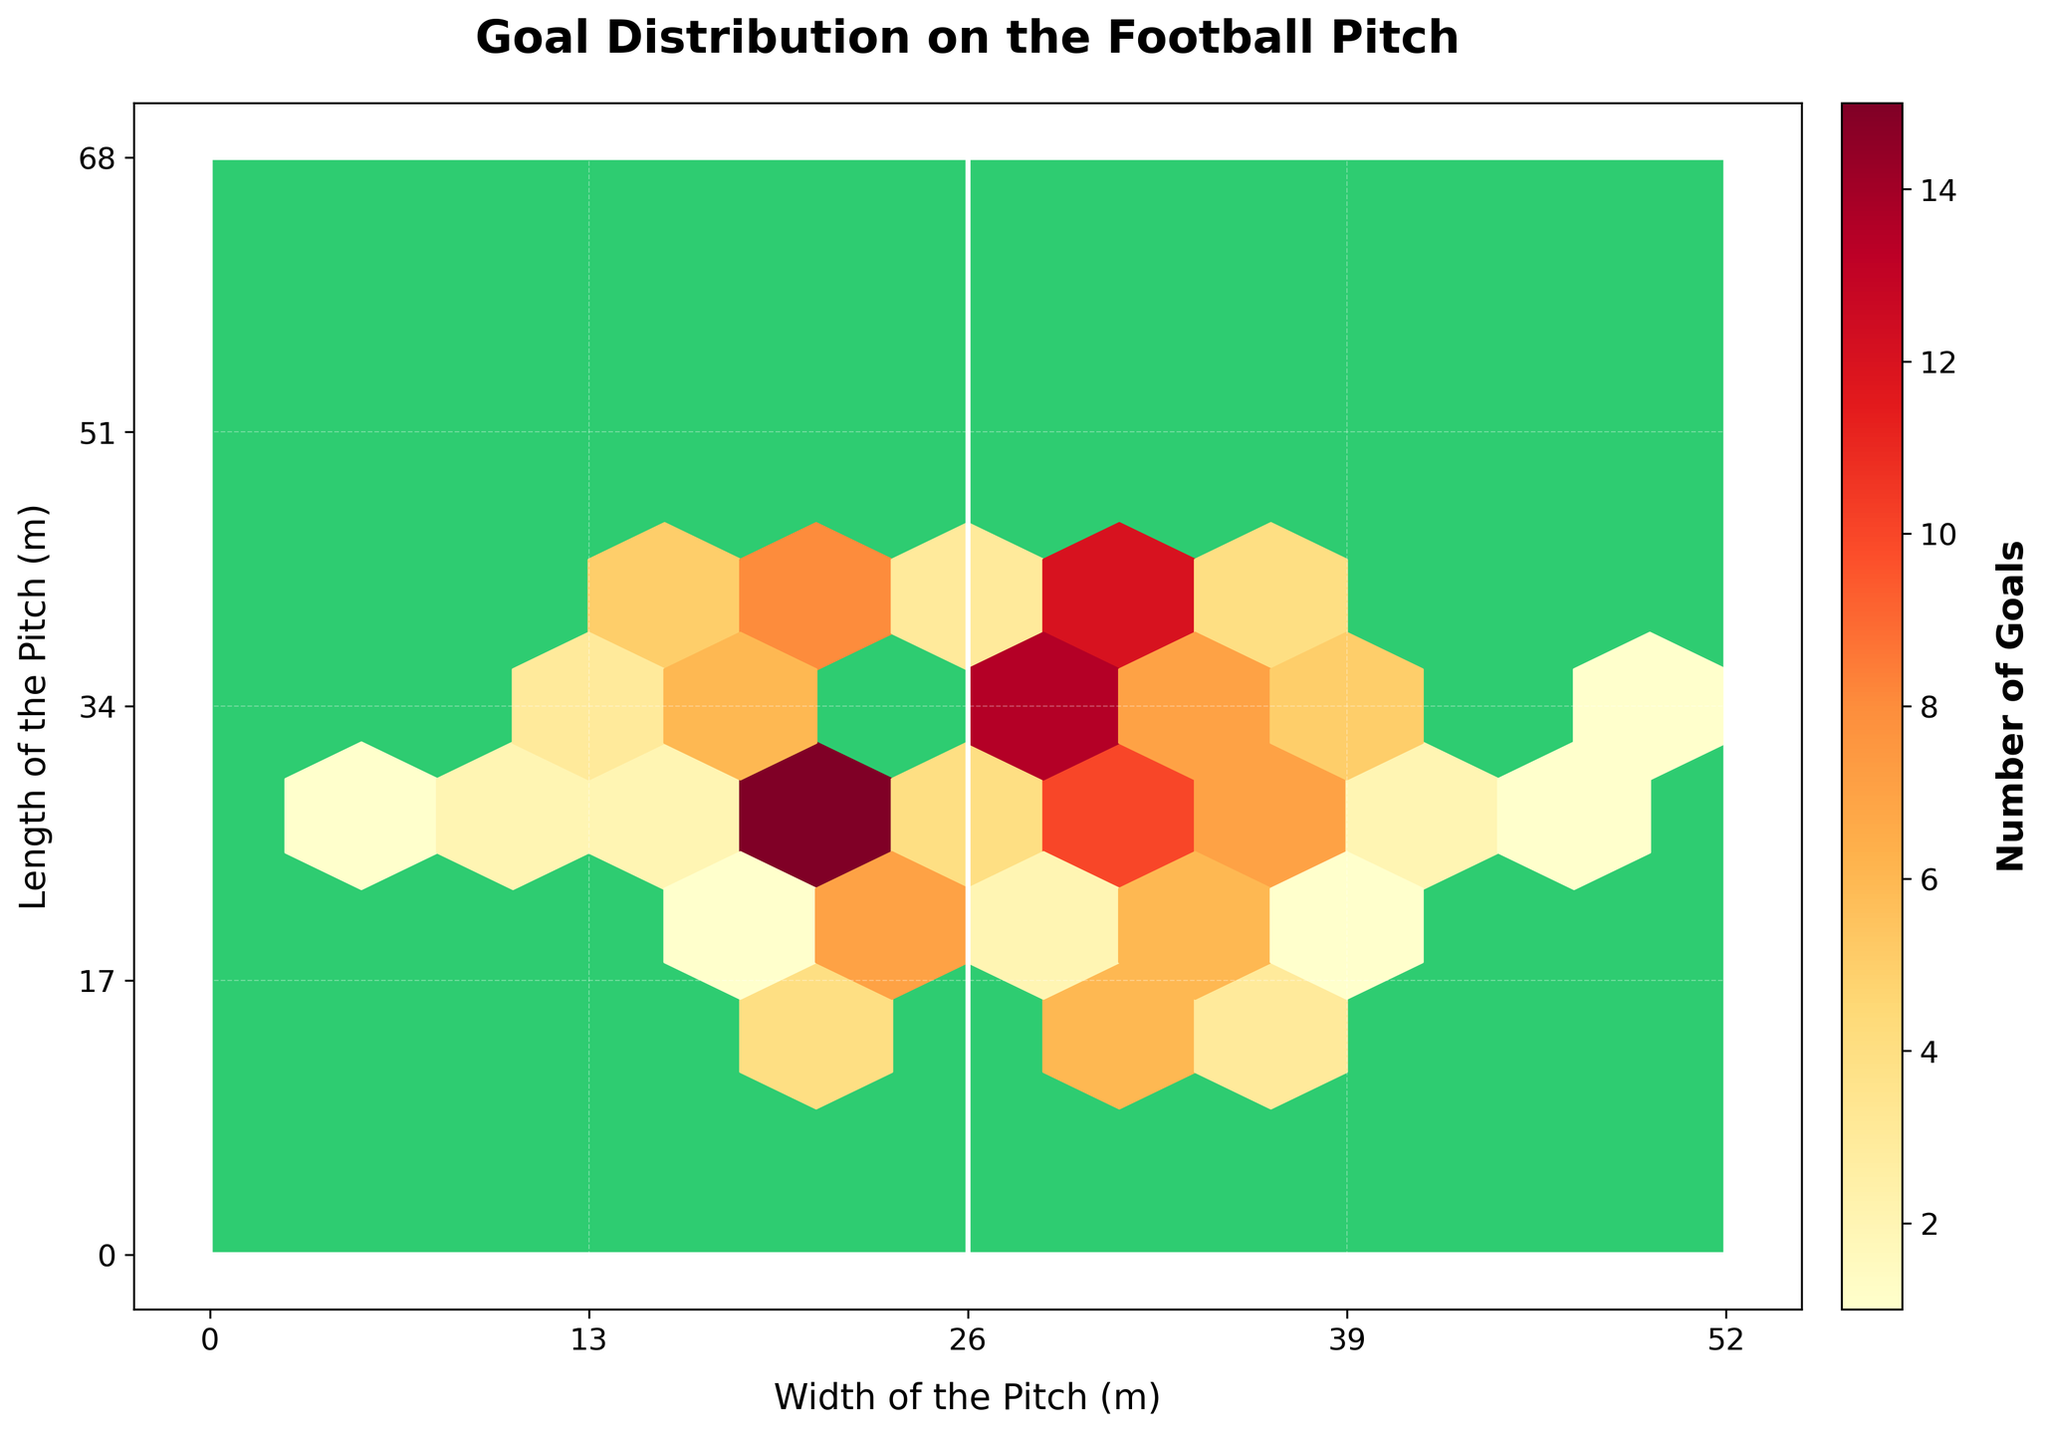What's the title of the plot? The title is prominently displayed at the top of the plot in bold. It summarizes the main subject of the visualization.
Answer: Goal Distribution on the Football Pitch What is the range of the x-axis? The x-axis represents the width of the pitch, starting from 0 and extending to 52 meters. This range is clearly marked on the axis.
Answer: 0 to 52 meters What color represents areas with the highest number of goals? The color used in the plot ranges from yellow to dark red, with dark red indicating the areas with the highest number of goals. This is evident from the color intensity in the hexbin plot and the corresponding color bar.
Answer: Dark red Where is the highest concentration of goals located on the pitch? By observing the concentration of dark red hexagons, the highest density of goals is located around the coordinates (30, 32), indicating a high frequency of goals scored in this area.
Answer: Around (30, 32) What is the minimum count of goals represented in the plot? The color bar indicates the range of goals, with the minimum value represented typically in the lighter shades. Here, yellow represents at least 1 goal.
Answer: 1 goal Which side of the pitch has more goal-scoring activity, left (0-26) or right (26-52)? By comparing the density and color intensity on both sides of the center line (at 26), the right side shows more dark red hexagons, indicating higher activity.
Answer: Right side How many distinct hexagons represent goal counts above 10? From the plot, we can count individual hexagons that are dark red or similarly intense shades to represent areas with more than 10 goals. There are three such hexagons.
Answer: 3 hexagons What is the median number of goals scored around the (26, 36) area? Around the coordinates (26, 36), the color indicates the number of goals. By looking at the nearest hexagons, we see values of 9 and 3; averaging these gives us an idea closer to the median value in this sparse area.
Answer: Approximately 6 goals Which position on the pitch (close to coordinates) has the lowest average goals per hexagon? The off-center areas along the width, like around (6, 30), have lighter hexagons which indicate fewer goals. Position around coordinates (6, 30) have hexagons showing values of 1.
Answer: Around (6, 30) Compare the goal distribution between the central and wing areas. The central areas (20-32, for most y-values) have higher concentrations and darker hexagons, showing more goals than the wing areas which are indicated by lighter hexagons.
Answer: Central areas have more goals What does the largest hexagon represent, and where is it located? In hexbin plots, larger hexagons indicate areas with higher density of goals. The largest hexagon is at the coordinate (30, 32) representing the highest concentration of 18 goals.
Answer: (30, 32), 18 goals 